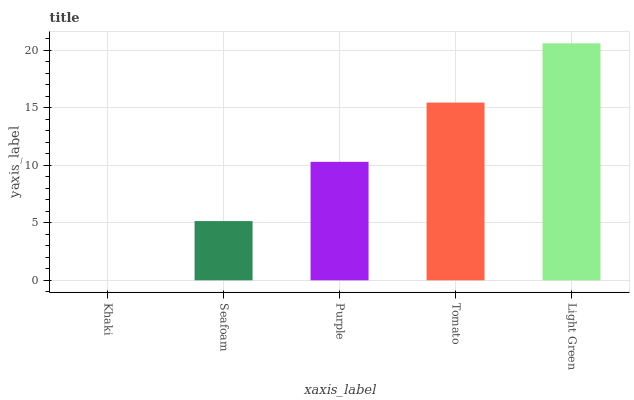Is Seafoam the minimum?
Answer yes or no. No. Is Seafoam the maximum?
Answer yes or no. No. Is Seafoam greater than Khaki?
Answer yes or no. Yes. Is Khaki less than Seafoam?
Answer yes or no. Yes. Is Khaki greater than Seafoam?
Answer yes or no. No. Is Seafoam less than Khaki?
Answer yes or no. No. Is Purple the high median?
Answer yes or no. Yes. Is Purple the low median?
Answer yes or no. Yes. Is Khaki the high median?
Answer yes or no. No. Is Tomato the low median?
Answer yes or no. No. 